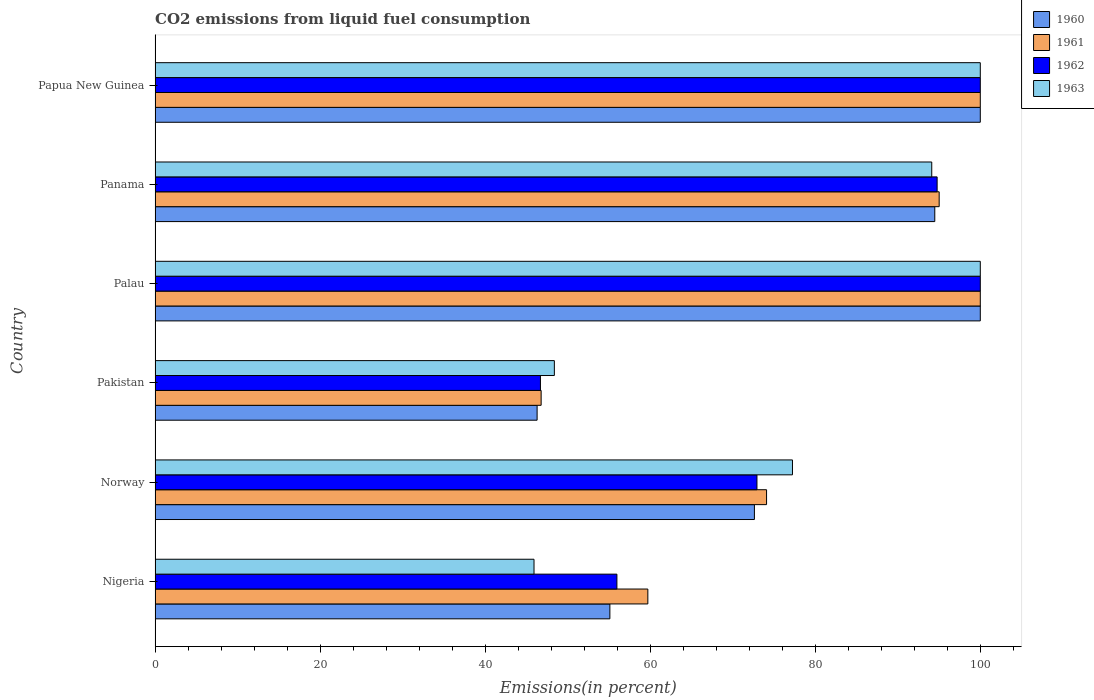How many groups of bars are there?
Give a very brief answer. 6. Are the number of bars on each tick of the Y-axis equal?
Provide a short and direct response. Yes. How many bars are there on the 5th tick from the top?
Offer a very short reply. 4. What is the label of the 3rd group of bars from the top?
Keep it short and to the point. Palau. In how many cases, is the number of bars for a given country not equal to the number of legend labels?
Offer a terse response. 0. Across all countries, what is the minimum total CO2 emitted in 1960?
Offer a very short reply. 46.3. In which country was the total CO2 emitted in 1960 maximum?
Your response must be concise. Palau. What is the total total CO2 emitted in 1962 in the graph?
Your answer should be compact. 470.37. What is the difference between the total CO2 emitted in 1961 in Norway and that in Pakistan?
Your answer should be very brief. 27.32. What is the difference between the total CO2 emitted in 1963 in Nigeria and the total CO2 emitted in 1960 in Palau?
Your response must be concise. -54.08. What is the average total CO2 emitted in 1960 per country?
Offer a very short reply. 78.09. What is the difference between the total CO2 emitted in 1960 and total CO2 emitted in 1961 in Norway?
Offer a very short reply. -1.47. In how many countries, is the total CO2 emitted in 1961 greater than 80 %?
Provide a short and direct response. 3. What is the ratio of the total CO2 emitted in 1961 in Norway to that in Pakistan?
Offer a terse response. 1.58. Is the difference between the total CO2 emitted in 1960 in Nigeria and Panama greater than the difference between the total CO2 emitted in 1961 in Nigeria and Panama?
Make the answer very short. No. What is the difference between the highest and the lowest total CO2 emitted in 1961?
Ensure brevity in your answer.  53.21. In how many countries, is the total CO2 emitted in 1960 greater than the average total CO2 emitted in 1960 taken over all countries?
Give a very brief answer. 3. Is the sum of the total CO2 emitted in 1961 in Nigeria and Papua New Guinea greater than the maximum total CO2 emitted in 1962 across all countries?
Keep it short and to the point. Yes. Is it the case that in every country, the sum of the total CO2 emitted in 1962 and total CO2 emitted in 1963 is greater than the sum of total CO2 emitted in 1961 and total CO2 emitted in 1960?
Offer a very short reply. No. What does the 3rd bar from the bottom in Panama represents?
Provide a succinct answer. 1962. How many bars are there?
Offer a very short reply. 24. Are all the bars in the graph horizontal?
Provide a succinct answer. Yes. What is the difference between two consecutive major ticks on the X-axis?
Your answer should be very brief. 20. Does the graph contain grids?
Make the answer very short. No. How many legend labels are there?
Ensure brevity in your answer.  4. How are the legend labels stacked?
Your response must be concise. Vertical. What is the title of the graph?
Offer a very short reply. CO2 emissions from liquid fuel consumption. Does "1969" appear as one of the legend labels in the graph?
Provide a short and direct response. No. What is the label or title of the X-axis?
Give a very brief answer. Emissions(in percent). What is the label or title of the Y-axis?
Offer a terse response. Country. What is the Emissions(in percent) of 1960 in Nigeria?
Give a very brief answer. 55.11. What is the Emissions(in percent) of 1961 in Nigeria?
Offer a terse response. 59.71. What is the Emissions(in percent) of 1962 in Nigeria?
Keep it short and to the point. 55.96. What is the Emissions(in percent) in 1963 in Nigeria?
Your answer should be compact. 45.92. What is the Emissions(in percent) in 1960 in Norway?
Offer a very short reply. 72.63. What is the Emissions(in percent) in 1961 in Norway?
Keep it short and to the point. 74.1. What is the Emissions(in percent) in 1962 in Norway?
Your answer should be very brief. 72.94. What is the Emissions(in percent) in 1963 in Norway?
Provide a succinct answer. 77.24. What is the Emissions(in percent) of 1960 in Pakistan?
Ensure brevity in your answer.  46.3. What is the Emissions(in percent) of 1961 in Pakistan?
Provide a succinct answer. 46.79. What is the Emissions(in percent) of 1962 in Pakistan?
Give a very brief answer. 46.7. What is the Emissions(in percent) of 1963 in Pakistan?
Your answer should be compact. 48.39. What is the Emissions(in percent) of 1961 in Palau?
Your response must be concise. 100. What is the Emissions(in percent) of 1962 in Palau?
Make the answer very short. 100. What is the Emissions(in percent) of 1963 in Palau?
Your answer should be very brief. 100. What is the Emissions(in percent) of 1960 in Panama?
Your answer should be very brief. 94.49. What is the Emissions(in percent) of 1961 in Panama?
Your answer should be very brief. 95.02. What is the Emissions(in percent) in 1962 in Panama?
Your answer should be very brief. 94.77. What is the Emissions(in percent) in 1963 in Panama?
Give a very brief answer. 94.12. What is the Emissions(in percent) in 1962 in Papua New Guinea?
Offer a terse response. 100. What is the Emissions(in percent) of 1963 in Papua New Guinea?
Your answer should be compact. 100. Across all countries, what is the maximum Emissions(in percent) of 1960?
Offer a terse response. 100. Across all countries, what is the maximum Emissions(in percent) in 1962?
Offer a terse response. 100. Across all countries, what is the maximum Emissions(in percent) in 1963?
Your answer should be very brief. 100. Across all countries, what is the minimum Emissions(in percent) of 1960?
Provide a succinct answer. 46.3. Across all countries, what is the minimum Emissions(in percent) of 1961?
Give a very brief answer. 46.79. Across all countries, what is the minimum Emissions(in percent) of 1962?
Offer a very short reply. 46.7. Across all countries, what is the minimum Emissions(in percent) in 1963?
Give a very brief answer. 45.92. What is the total Emissions(in percent) in 1960 in the graph?
Offer a very short reply. 468.52. What is the total Emissions(in percent) of 1961 in the graph?
Offer a terse response. 475.62. What is the total Emissions(in percent) in 1962 in the graph?
Provide a short and direct response. 470.37. What is the total Emissions(in percent) of 1963 in the graph?
Provide a succinct answer. 465.66. What is the difference between the Emissions(in percent) in 1960 in Nigeria and that in Norway?
Keep it short and to the point. -17.52. What is the difference between the Emissions(in percent) of 1961 in Nigeria and that in Norway?
Offer a very short reply. -14.39. What is the difference between the Emissions(in percent) in 1962 in Nigeria and that in Norway?
Keep it short and to the point. -16.97. What is the difference between the Emissions(in percent) in 1963 in Nigeria and that in Norway?
Provide a succinct answer. -31.32. What is the difference between the Emissions(in percent) in 1960 in Nigeria and that in Pakistan?
Offer a terse response. 8.82. What is the difference between the Emissions(in percent) in 1961 in Nigeria and that in Pakistan?
Your answer should be compact. 12.93. What is the difference between the Emissions(in percent) of 1962 in Nigeria and that in Pakistan?
Offer a very short reply. 9.27. What is the difference between the Emissions(in percent) in 1963 in Nigeria and that in Pakistan?
Your answer should be very brief. -2.46. What is the difference between the Emissions(in percent) in 1960 in Nigeria and that in Palau?
Your response must be concise. -44.89. What is the difference between the Emissions(in percent) in 1961 in Nigeria and that in Palau?
Provide a succinct answer. -40.29. What is the difference between the Emissions(in percent) in 1962 in Nigeria and that in Palau?
Provide a short and direct response. -44.04. What is the difference between the Emissions(in percent) of 1963 in Nigeria and that in Palau?
Keep it short and to the point. -54.08. What is the difference between the Emissions(in percent) in 1960 in Nigeria and that in Panama?
Offer a very short reply. -39.37. What is the difference between the Emissions(in percent) of 1961 in Nigeria and that in Panama?
Offer a very short reply. -35.3. What is the difference between the Emissions(in percent) of 1962 in Nigeria and that in Panama?
Your response must be concise. -38.8. What is the difference between the Emissions(in percent) of 1963 in Nigeria and that in Panama?
Keep it short and to the point. -48.2. What is the difference between the Emissions(in percent) in 1960 in Nigeria and that in Papua New Guinea?
Ensure brevity in your answer.  -44.89. What is the difference between the Emissions(in percent) in 1961 in Nigeria and that in Papua New Guinea?
Your answer should be very brief. -40.29. What is the difference between the Emissions(in percent) in 1962 in Nigeria and that in Papua New Guinea?
Your answer should be very brief. -44.04. What is the difference between the Emissions(in percent) in 1963 in Nigeria and that in Papua New Guinea?
Offer a terse response. -54.08. What is the difference between the Emissions(in percent) in 1960 in Norway and that in Pakistan?
Your response must be concise. 26.33. What is the difference between the Emissions(in percent) in 1961 in Norway and that in Pakistan?
Give a very brief answer. 27.32. What is the difference between the Emissions(in percent) of 1962 in Norway and that in Pakistan?
Your response must be concise. 26.24. What is the difference between the Emissions(in percent) of 1963 in Norway and that in Pakistan?
Make the answer very short. 28.85. What is the difference between the Emissions(in percent) of 1960 in Norway and that in Palau?
Make the answer very short. -27.37. What is the difference between the Emissions(in percent) in 1961 in Norway and that in Palau?
Ensure brevity in your answer.  -25.9. What is the difference between the Emissions(in percent) of 1962 in Norway and that in Palau?
Keep it short and to the point. -27.06. What is the difference between the Emissions(in percent) in 1963 in Norway and that in Palau?
Offer a very short reply. -22.76. What is the difference between the Emissions(in percent) in 1960 in Norway and that in Panama?
Your answer should be very brief. -21.86. What is the difference between the Emissions(in percent) in 1961 in Norway and that in Panama?
Give a very brief answer. -20.92. What is the difference between the Emissions(in percent) in 1962 in Norway and that in Panama?
Provide a succinct answer. -21.83. What is the difference between the Emissions(in percent) of 1963 in Norway and that in Panama?
Offer a terse response. -16.88. What is the difference between the Emissions(in percent) of 1960 in Norway and that in Papua New Guinea?
Your response must be concise. -27.37. What is the difference between the Emissions(in percent) in 1961 in Norway and that in Papua New Guinea?
Provide a short and direct response. -25.9. What is the difference between the Emissions(in percent) in 1962 in Norway and that in Papua New Guinea?
Ensure brevity in your answer.  -27.06. What is the difference between the Emissions(in percent) in 1963 in Norway and that in Papua New Guinea?
Give a very brief answer. -22.76. What is the difference between the Emissions(in percent) in 1960 in Pakistan and that in Palau?
Make the answer very short. -53.7. What is the difference between the Emissions(in percent) of 1961 in Pakistan and that in Palau?
Ensure brevity in your answer.  -53.21. What is the difference between the Emissions(in percent) of 1962 in Pakistan and that in Palau?
Offer a terse response. -53.3. What is the difference between the Emissions(in percent) of 1963 in Pakistan and that in Palau?
Offer a very short reply. -51.61. What is the difference between the Emissions(in percent) of 1960 in Pakistan and that in Panama?
Your answer should be compact. -48.19. What is the difference between the Emissions(in percent) in 1961 in Pakistan and that in Panama?
Your response must be concise. -48.23. What is the difference between the Emissions(in percent) in 1962 in Pakistan and that in Panama?
Offer a terse response. -48.07. What is the difference between the Emissions(in percent) in 1963 in Pakistan and that in Panama?
Offer a terse response. -45.73. What is the difference between the Emissions(in percent) in 1960 in Pakistan and that in Papua New Guinea?
Make the answer very short. -53.7. What is the difference between the Emissions(in percent) of 1961 in Pakistan and that in Papua New Guinea?
Offer a terse response. -53.21. What is the difference between the Emissions(in percent) of 1962 in Pakistan and that in Papua New Guinea?
Provide a succinct answer. -53.3. What is the difference between the Emissions(in percent) of 1963 in Pakistan and that in Papua New Guinea?
Your answer should be compact. -51.61. What is the difference between the Emissions(in percent) of 1960 in Palau and that in Panama?
Your response must be concise. 5.51. What is the difference between the Emissions(in percent) in 1961 in Palau and that in Panama?
Provide a short and direct response. 4.98. What is the difference between the Emissions(in percent) of 1962 in Palau and that in Panama?
Your answer should be compact. 5.23. What is the difference between the Emissions(in percent) in 1963 in Palau and that in Panama?
Give a very brief answer. 5.88. What is the difference between the Emissions(in percent) in 1960 in Palau and that in Papua New Guinea?
Offer a very short reply. 0. What is the difference between the Emissions(in percent) of 1961 in Palau and that in Papua New Guinea?
Offer a terse response. 0. What is the difference between the Emissions(in percent) of 1962 in Palau and that in Papua New Guinea?
Offer a terse response. 0. What is the difference between the Emissions(in percent) of 1960 in Panama and that in Papua New Guinea?
Keep it short and to the point. -5.51. What is the difference between the Emissions(in percent) in 1961 in Panama and that in Papua New Guinea?
Your response must be concise. -4.98. What is the difference between the Emissions(in percent) of 1962 in Panama and that in Papua New Guinea?
Offer a very short reply. -5.23. What is the difference between the Emissions(in percent) in 1963 in Panama and that in Papua New Guinea?
Your response must be concise. -5.88. What is the difference between the Emissions(in percent) in 1960 in Nigeria and the Emissions(in percent) in 1961 in Norway?
Your answer should be very brief. -18.99. What is the difference between the Emissions(in percent) in 1960 in Nigeria and the Emissions(in percent) in 1962 in Norway?
Your answer should be very brief. -17.82. What is the difference between the Emissions(in percent) in 1960 in Nigeria and the Emissions(in percent) in 1963 in Norway?
Your response must be concise. -22.13. What is the difference between the Emissions(in percent) of 1961 in Nigeria and the Emissions(in percent) of 1962 in Norway?
Give a very brief answer. -13.22. What is the difference between the Emissions(in percent) of 1961 in Nigeria and the Emissions(in percent) of 1963 in Norway?
Your answer should be compact. -17.52. What is the difference between the Emissions(in percent) in 1962 in Nigeria and the Emissions(in percent) in 1963 in Norway?
Give a very brief answer. -21.27. What is the difference between the Emissions(in percent) in 1960 in Nigeria and the Emissions(in percent) in 1961 in Pakistan?
Your answer should be compact. 8.33. What is the difference between the Emissions(in percent) in 1960 in Nigeria and the Emissions(in percent) in 1962 in Pakistan?
Make the answer very short. 8.41. What is the difference between the Emissions(in percent) in 1960 in Nigeria and the Emissions(in percent) in 1963 in Pakistan?
Provide a short and direct response. 6.73. What is the difference between the Emissions(in percent) of 1961 in Nigeria and the Emissions(in percent) of 1962 in Pakistan?
Provide a succinct answer. 13.02. What is the difference between the Emissions(in percent) in 1961 in Nigeria and the Emissions(in percent) in 1963 in Pakistan?
Keep it short and to the point. 11.33. What is the difference between the Emissions(in percent) in 1962 in Nigeria and the Emissions(in percent) in 1963 in Pakistan?
Your answer should be very brief. 7.58. What is the difference between the Emissions(in percent) of 1960 in Nigeria and the Emissions(in percent) of 1961 in Palau?
Provide a short and direct response. -44.89. What is the difference between the Emissions(in percent) in 1960 in Nigeria and the Emissions(in percent) in 1962 in Palau?
Make the answer very short. -44.89. What is the difference between the Emissions(in percent) in 1960 in Nigeria and the Emissions(in percent) in 1963 in Palau?
Ensure brevity in your answer.  -44.89. What is the difference between the Emissions(in percent) in 1961 in Nigeria and the Emissions(in percent) in 1962 in Palau?
Your answer should be very brief. -40.29. What is the difference between the Emissions(in percent) of 1961 in Nigeria and the Emissions(in percent) of 1963 in Palau?
Your answer should be compact. -40.29. What is the difference between the Emissions(in percent) of 1962 in Nigeria and the Emissions(in percent) of 1963 in Palau?
Make the answer very short. -44.04. What is the difference between the Emissions(in percent) of 1960 in Nigeria and the Emissions(in percent) of 1961 in Panama?
Ensure brevity in your answer.  -39.9. What is the difference between the Emissions(in percent) in 1960 in Nigeria and the Emissions(in percent) in 1962 in Panama?
Your response must be concise. -39.66. What is the difference between the Emissions(in percent) in 1960 in Nigeria and the Emissions(in percent) in 1963 in Panama?
Provide a short and direct response. -39. What is the difference between the Emissions(in percent) of 1961 in Nigeria and the Emissions(in percent) of 1962 in Panama?
Keep it short and to the point. -35.05. What is the difference between the Emissions(in percent) in 1961 in Nigeria and the Emissions(in percent) in 1963 in Panama?
Offer a very short reply. -34.4. What is the difference between the Emissions(in percent) in 1962 in Nigeria and the Emissions(in percent) in 1963 in Panama?
Offer a very short reply. -38.15. What is the difference between the Emissions(in percent) of 1960 in Nigeria and the Emissions(in percent) of 1961 in Papua New Guinea?
Your response must be concise. -44.89. What is the difference between the Emissions(in percent) in 1960 in Nigeria and the Emissions(in percent) in 1962 in Papua New Guinea?
Provide a short and direct response. -44.89. What is the difference between the Emissions(in percent) in 1960 in Nigeria and the Emissions(in percent) in 1963 in Papua New Guinea?
Offer a very short reply. -44.89. What is the difference between the Emissions(in percent) in 1961 in Nigeria and the Emissions(in percent) in 1962 in Papua New Guinea?
Offer a terse response. -40.29. What is the difference between the Emissions(in percent) of 1961 in Nigeria and the Emissions(in percent) of 1963 in Papua New Guinea?
Give a very brief answer. -40.29. What is the difference between the Emissions(in percent) in 1962 in Nigeria and the Emissions(in percent) in 1963 in Papua New Guinea?
Ensure brevity in your answer.  -44.04. What is the difference between the Emissions(in percent) in 1960 in Norway and the Emissions(in percent) in 1961 in Pakistan?
Offer a terse response. 25.84. What is the difference between the Emissions(in percent) of 1960 in Norway and the Emissions(in percent) of 1962 in Pakistan?
Keep it short and to the point. 25.93. What is the difference between the Emissions(in percent) of 1960 in Norway and the Emissions(in percent) of 1963 in Pakistan?
Your answer should be compact. 24.24. What is the difference between the Emissions(in percent) in 1961 in Norway and the Emissions(in percent) in 1962 in Pakistan?
Your answer should be very brief. 27.4. What is the difference between the Emissions(in percent) in 1961 in Norway and the Emissions(in percent) in 1963 in Pakistan?
Offer a terse response. 25.71. What is the difference between the Emissions(in percent) in 1962 in Norway and the Emissions(in percent) in 1963 in Pakistan?
Make the answer very short. 24.55. What is the difference between the Emissions(in percent) of 1960 in Norway and the Emissions(in percent) of 1961 in Palau?
Make the answer very short. -27.37. What is the difference between the Emissions(in percent) of 1960 in Norway and the Emissions(in percent) of 1962 in Palau?
Keep it short and to the point. -27.37. What is the difference between the Emissions(in percent) of 1960 in Norway and the Emissions(in percent) of 1963 in Palau?
Your answer should be compact. -27.37. What is the difference between the Emissions(in percent) in 1961 in Norway and the Emissions(in percent) in 1962 in Palau?
Your answer should be very brief. -25.9. What is the difference between the Emissions(in percent) in 1961 in Norway and the Emissions(in percent) in 1963 in Palau?
Your answer should be very brief. -25.9. What is the difference between the Emissions(in percent) in 1962 in Norway and the Emissions(in percent) in 1963 in Palau?
Offer a very short reply. -27.06. What is the difference between the Emissions(in percent) of 1960 in Norway and the Emissions(in percent) of 1961 in Panama?
Make the answer very short. -22.39. What is the difference between the Emissions(in percent) of 1960 in Norway and the Emissions(in percent) of 1962 in Panama?
Your response must be concise. -22.14. What is the difference between the Emissions(in percent) in 1960 in Norway and the Emissions(in percent) in 1963 in Panama?
Provide a succinct answer. -21.49. What is the difference between the Emissions(in percent) in 1961 in Norway and the Emissions(in percent) in 1962 in Panama?
Make the answer very short. -20.67. What is the difference between the Emissions(in percent) in 1961 in Norway and the Emissions(in percent) in 1963 in Panama?
Your answer should be compact. -20.02. What is the difference between the Emissions(in percent) in 1962 in Norway and the Emissions(in percent) in 1963 in Panama?
Offer a very short reply. -21.18. What is the difference between the Emissions(in percent) in 1960 in Norway and the Emissions(in percent) in 1961 in Papua New Guinea?
Give a very brief answer. -27.37. What is the difference between the Emissions(in percent) in 1960 in Norway and the Emissions(in percent) in 1962 in Papua New Guinea?
Offer a terse response. -27.37. What is the difference between the Emissions(in percent) of 1960 in Norway and the Emissions(in percent) of 1963 in Papua New Guinea?
Provide a succinct answer. -27.37. What is the difference between the Emissions(in percent) of 1961 in Norway and the Emissions(in percent) of 1962 in Papua New Guinea?
Make the answer very short. -25.9. What is the difference between the Emissions(in percent) in 1961 in Norway and the Emissions(in percent) in 1963 in Papua New Guinea?
Make the answer very short. -25.9. What is the difference between the Emissions(in percent) of 1962 in Norway and the Emissions(in percent) of 1963 in Papua New Guinea?
Offer a terse response. -27.06. What is the difference between the Emissions(in percent) in 1960 in Pakistan and the Emissions(in percent) in 1961 in Palau?
Your answer should be very brief. -53.7. What is the difference between the Emissions(in percent) of 1960 in Pakistan and the Emissions(in percent) of 1962 in Palau?
Your answer should be compact. -53.7. What is the difference between the Emissions(in percent) of 1960 in Pakistan and the Emissions(in percent) of 1963 in Palau?
Make the answer very short. -53.7. What is the difference between the Emissions(in percent) in 1961 in Pakistan and the Emissions(in percent) in 1962 in Palau?
Offer a terse response. -53.21. What is the difference between the Emissions(in percent) in 1961 in Pakistan and the Emissions(in percent) in 1963 in Palau?
Ensure brevity in your answer.  -53.21. What is the difference between the Emissions(in percent) of 1962 in Pakistan and the Emissions(in percent) of 1963 in Palau?
Provide a succinct answer. -53.3. What is the difference between the Emissions(in percent) of 1960 in Pakistan and the Emissions(in percent) of 1961 in Panama?
Provide a short and direct response. -48.72. What is the difference between the Emissions(in percent) in 1960 in Pakistan and the Emissions(in percent) in 1962 in Panama?
Your response must be concise. -48.47. What is the difference between the Emissions(in percent) in 1960 in Pakistan and the Emissions(in percent) in 1963 in Panama?
Provide a succinct answer. -47.82. What is the difference between the Emissions(in percent) of 1961 in Pakistan and the Emissions(in percent) of 1962 in Panama?
Your answer should be very brief. -47.98. What is the difference between the Emissions(in percent) of 1961 in Pakistan and the Emissions(in percent) of 1963 in Panama?
Your response must be concise. -47.33. What is the difference between the Emissions(in percent) in 1962 in Pakistan and the Emissions(in percent) in 1963 in Panama?
Offer a very short reply. -47.42. What is the difference between the Emissions(in percent) of 1960 in Pakistan and the Emissions(in percent) of 1961 in Papua New Guinea?
Ensure brevity in your answer.  -53.7. What is the difference between the Emissions(in percent) of 1960 in Pakistan and the Emissions(in percent) of 1962 in Papua New Guinea?
Offer a very short reply. -53.7. What is the difference between the Emissions(in percent) in 1960 in Pakistan and the Emissions(in percent) in 1963 in Papua New Guinea?
Provide a short and direct response. -53.7. What is the difference between the Emissions(in percent) of 1961 in Pakistan and the Emissions(in percent) of 1962 in Papua New Guinea?
Your answer should be very brief. -53.21. What is the difference between the Emissions(in percent) of 1961 in Pakistan and the Emissions(in percent) of 1963 in Papua New Guinea?
Your answer should be very brief. -53.21. What is the difference between the Emissions(in percent) in 1962 in Pakistan and the Emissions(in percent) in 1963 in Papua New Guinea?
Provide a succinct answer. -53.3. What is the difference between the Emissions(in percent) of 1960 in Palau and the Emissions(in percent) of 1961 in Panama?
Your response must be concise. 4.98. What is the difference between the Emissions(in percent) in 1960 in Palau and the Emissions(in percent) in 1962 in Panama?
Your answer should be compact. 5.23. What is the difference between the Emissions(in percent) of 1960 in Palau and the Emissions(in percent) of 1963 in Panama?
Ensure brevity in your answer.  5.88. What is the difference between the Emissions(in percent) in 1961 in Palau and the Emissions(in percent) in 1962 in Panama?
Offer a very short reply. 5.23. What is the difference between the Emissions(in percent) of 1961 in Palau and the Emissions(in percent) of 1963 in Panama?
Keep it short and to the point. 5.88. What is the difference between the Emissions(in percent) in 1962 in Palau and the Emissions(in percent) in 1963 in Panama?
Ensure brevity in your answer.  5.88. What is the difference between the Emissions(in percent) in 1960 in Palau and the Emissions(in percent) in 1962 in Papua New Guinea?
Make the answer very short. 0. What is the difference between the Emissions(in percent) in 1960 in Palau and the Emissions(in percent) in 1963 in Papua New Guinea?
Keep it short and to the point. 0. What is the difference between the Emissions(in percent) in 1961 in Palau and the Emissions(in percent) in 1962 in Papua New Guinea?
Make the answer very short. 0. What is the difference between the Emissions(in percent) of 1961 in Palau and the Emissions(in percent) of 1963 in Papua New Guinea?
Your answer should be compact. 0. What is the difference between the Emissions(in percent) of 1960 in Panama and the Emissions(in percent) of 1961 in Papua New Guinea?
Keep it short and to the point. -5.51. What is the difference between the Emissions(in percent) in 1960 in Panama and the Emissions(in percent) in 1962 in Papua New Guinea?
Your answer should be compact. -5.51. What is the difference between the Emissions(in percent) of 1960 in Panama and the Emissions(in percent) of 1963 in Papua New Guinea?
Provide a short and direct response. -5.51. What is the difference between the Emissions(in percent) of 1961 in Panama and the Emissions(in percent) of 1962 in Papua New Guinea?
Ensure brevity in your answer.  -4.98. What is the difference between the Emissions(in percent) of 1961 in Panama and the Emissions(in percent) of 1963 in Papua New Guinea?
Your answer should be very brief. -4.98. What is the difference between the Emissions(in percent) of 1962 in Panama and the Emissions(in percent) of 1963 in Papua New Guinea?
Your response must be concise. -5.23. What is the average Emissions(in percent) of 1960 per country?
Give a very brief answer. 78.09. What is the average Emissions(in percent) of 1961 per country?
Keep it short and to the point. 79.27. What is the average Emissions(in percent) of 1962 per country?
Offer a very short reply. 78.39. What is the average Emissions(in percent) in 1963 per country?
Offer a terse response. 77.61. What is the difference between the Emissions(in percent) of 1960 and Emissions(in percent) of 1961 in Nigeria?
Ensure brevity in your answer.  -4.6. What is the difference between the Emissions(in percent) in 1960 and Emissions(in percent) in 1962 in Nigeria?
Provide a succinct answer. -0.85. What is the difference between the Emissions(in percent) of 1960 and Emissions(in percent) of 1963 in Nigeria?
Make the answer very short. 9.19. What is the difference between the Emissions(in percent) in 1961 and Emissions(in percent) in 1962 in Nigeria?
Your answer should be compact. 3.75. What is the difference between the Emissions(in percent) in 1961 and Emissions(in percent) in 1963 in Nigeria?
Offer a terse response. 13.79. What is the difference between the Emissions(in percent) of 1962 and Emissions(in percent) of 1963 in Nigeria?
Your answer should be compact. 10.04. What is the difference between the Emissions(in percent) in 1960 and Emissions(in percent) in 1961 in Norway?
Your response must be concise. -1.47. What is the difference between the Emissions(in percent) of 1960 and Emissions(in percent) of 1962 in Norway?
Your answer should be very brief. -0.31. What is the difference between the Emissions(in percent) in 1960 and Emissions(in percent) in 1963 in Norway?
Provide a short and direct response. -4.61. What is the difference between the Emissions(in percent) in 1961 and Emissions(in percent) in 1962 in Norway?
Give a very brief answer. 1.16. What is the difference between the Emissions(in percent) in 1961 and Emissions(in percent) in 1963 in Norway?
Ensure brevity in your answer.  -3.14. What is the difference between the Emissions(in percent) of 1962 and Emissions(in percent) of 1963 in Norway?
Your answer should be very brief. -4.3. What is the difference between the Emissions(in percent) in 1960 and Emissions(in percent) in 1961 in Pakistan?
Offer a terse response. -0.49. What is the difference between the Emissions(in percent) of 1960 and Emissions(in percent) of 1962 in Pakistan?
Keep it short and to the point. -0.4. What is the difference between the Emissions(in percent) of 1960 and Emissions(in percent) of 1963 in Pakistan?
Your answer should be very brief. -2.09. What is the difference between the Emissions(in percent) of 1961 and Emissions(in percent) of 1962 in Pakistan?
Give a very brief answer. 0.09. What is the difference between the Emissions(in percent) in 1961 and Emissions(in percent) in 1963 in Pakistan?
Offer a terse response. -1.6. What is the difference between the Emissions(in percent) of 1962 and Emissions(in percent) of 1963 in Pakistan?
Offer a very short reply. -1.69. What is the difference between the Emissions(in percent) in 1960 and Emissions(in percent) in 1963 in Palau?
Ensure brevity in your answer.  0. What is the difference between the Emissions(in percent) in 1961 and Emissions(in percent) in 1963 in Palau?
Your response must be concise. 0. What is the difference between the Emissions(in percent) of 1962 and Emissions(in percent) of 1963 in Palau?
Your answer should be very brief. 0. What is the difference between the Emissions(in percent) in 1960 and Emissions(in percent) in 1961 in Panama?
Provide a short and direct response. -0.53. What is the difference between the Emissions(in percent) in 1960 and Emissions(in percent) in 1962 in Panama?
Your answer should be compact. -0.28. What is the difference between the Emissions(in percent) of 1960 and Emissions(in percent) of 1963 in Panama?
Ensure brevity in your answer.  0.37. What is the difference between the Emissions(in percent) in 1961 and Emissions(in percent) in 1962 in Panama?
Give a very brief answer. 0.25. What is the difference between the Emissions(in percent) of 1961 and Emissions(in percent) of 1963 in Panama?
Provide a succinct answer. 0.9. What is the difference between the Emissions(in percent) in 1962 and Emissions(in percent) in 1963 in Panama?
Your response must be concise. 0.65. What is the difference between the Emissions(in percent) of 1960 and Emissions(in percent) of 1961 in Papua New Guinea?
Make the answer very short. 0. What is the difference between the Emissions(in percent) in 1960 and Emissions(in percent) in 1963 in Papua New Guinea?
Your answer should be compact. 0. What is the difference between the Emissions(in percent) of 1961 and Emissions(in percent) of 1962 in Papua New Guinea?
Make the answer very short. 0. What is the difference between the Emissions(in percent) of 1962 and Emissions(in percent) of 1963 in Papua New Guinea?
Provide a short and direct response. 0. What is the ratio of the Emissions(in percent) of 1960 in Nigeria to that in Norway?
Your answer should be very brief. 0.76. What is the ratio of the Emissions(in percent) in 1961 in Nigeria to that in Norway?
Provide a succinct answer. 0.81. What is the ratio of the Emissions(in percent) in 1962 in Nigeria to that in Norway?
Give a very brief answer. 0.77. What is the ratio of the Emissions(in percent) of 1963 in Nigeria to that in Norway?
Make the answer very short. 0.59. What is the ratio of the Emissions(in percent) in 1960 in Nigeria to that in Pakistan?
Provide a succinct answer. 1.19. What is the ratio of the Emissions(in percent) of 1961 in Nigeria to that in Pakistan?
Provide a succinct answer. 1.28. What is the ratio of the Emissions(in percent) of 1962 in Nigeria to that in Pakistan?
Your answer should be compact. 1.2. What is the ratio of the Emissions(in percent) in 1963 in Nigeria to that in Pakistan?
Make the answer very short. 0.95. What is the ratio of the Emissions(in percent) in 1960 in Nigeria to that in Palau?
Keep it short and to the point. 0.55. What is the ratio of the Emissions(in percent) in 1961 in Nigeria to that in Palau?
Keep it short and to the point. 0.6. What is the ratio of the Emissions(in percent) in 1962 in Nigeria to that in Palau?
Offer a very short reply. 0.56. What is the ratio of the Emissions(in percent) of 1963 in Nigeria to that in Palau?
Your response must be concise. 0.46. What is the ratio of the Emissions(in percent) in 1960 in Nigeria to that in Panama?
Offer a very short reply. 0.58. What is the ratio of the Emissions(in percent) in 1961 in Nigeria to that in Panama?
Offer a terse response. 0.63. What is the ratio of the Emissions(in percent) in 1962 in Nigeria to that in Panama?
Give a very brief answer. 0.59. What is the ratio of the Emissions(in percent) in 1963 in Nigeria to that in Panama?
Keep it short and to the point. 0.49. What is the ratio of the Emissions(in percent) in 1960 in Nigeria to that in Papua New Guinea?
Provide a succinct answer. 0.55. What is the ratio of the Emissions(in percent) of 1961 in Nigeria to that in Papua New Guinea?
Provide a short and direct response. 0.6. What is the ratio of the Emissions(in percent) of 1962 in Nigeria to that in Papua New Guinea?
Your answer should be compact. 0.56. What is the ratio of the Emissions(in percent) of 1963 in Nigeria to that in Papua New Guinea?
Give a very brief answer. 0.46. What is the ratio of the Emissions(in percent) in 1960 in Norway to that in Pakistan?
Give a very brief answer. 1.57. What is the ratio of the Emissions(in percent) of 1961 in Norway to that in Pakistan?
Your answer should be very brief. 1.58. What is the ratio of the Emissions(in percent) in 1962 in Norway to that in Pakistan?
Give a very brief answer. 1.56. What is the ratio of the Emissions(in percent) in 1963 in Norway to that in Pakistan?
Provide a succinct answer. 1.6. What is the ratio of the Emissions(in percent) in 1960 in Norway to that in Palau?
Offer a very short reply. 0.73. What is the ratio of the Emissions(in percent) in 1961 in Norway to that in Palau?
Your answer should be compact. 0.74. What is the ratio of the Emissions(in percent) in 1962 in Norway to that in Palau?
Keep it short and to the point. 0.73. What is the ratio of the Emissions(in percent) of 1963 in Norway to that in Palau?
Provide a succinct answer. 0.77. What is the ratio of the Emissions(in percent) in 1960 in Norway to that in Panama?
Your answer should be compact. 0.77. What is the ratio of the Emissions(in percent) of 1961 in Norway to that in Panama?
Offer a very short reply. 0.78. What is the ratio of the Emissions(in percent) of 1962 in Norway to that in Panama?
Offer a terse response. 0.77. What is the ratio of the Emissions(in percent) of 1963 in Norway to that in Panama?
Keep it short and to the point. 0.82. What is the ratio of the Emissions(in percent) in 1960 in Norway to that in Papua New Guinea?
Keep it short and to the point. 0.73. What is the ratio of the Emissions(in percent) in 1961 in Norway to that in Papua New Guinea?
Provide a short and direct response. 0.74. What is the ratio of the Emissions(in percent) of 1962 in Norway to that in Papua New Guinea?
Offer a very short reply. 0.73. What is the ratio of the Emissions(in percent) in 1963 in Norway to that in Papua New Guinea?
Your answer should be very brief. 0.77. What is the ratio of the Emissions(in percent) of 1960 in Pakistan to that in Palau?
Provide a short and direct response. 0.46. What is the ratio of the Emissions(in percent) of 1961 in Pakistan to that in Palau?
Your answer should be compact. 0.47. What is the ratio of the Emissions(in percent) in 1962 in Pakistan to that in Palau?
Your answer should be very brief. 0.47. What is the ratio of the Emissions(in percent) of 1963 in Pakistan to that in Palau?
Offer a terse response. 0.48. What is the ratio of the Emissions(in percent) of 1960 in Pakistan to that in Panama?
Offer a very short reply. 0.49. What is the ratio of the Emissions(in percent) of 1961 in Pakistan to that in Panama?
Provide a succinct answer. 0.49. What is the ratio of the Emissions(in percent) in 1962 in Pakistan to that in Panama?
Keep it short and to the point. 0.49. What is the ratio of the Emissions(in percent) of 1963 in Pakistan to that in Panama?
Offer a very short reply. 0.51. What is the ratio of the Emissions(in percent) of 1960 in Pakistan to that in Papua New Guinea?
Your answer should be very brief. 0.46. What is the ratio of the Emissions(in percent) in 1961 in Pakistan to that in Papua New Guinea?
Offer a terse response. 0.47. What is the ratio of the Emissions(in percent) of 1962 in Pakistan to that in Papua New Guinea?
Your answer should be compact. 0.47. What is the ratio of the Emissions(in percent) in 1963 in Pakistan to that in Papua New Guinea?
Your answer should be compact. 0.48. What is the ratio of the Emissions(in percent) of 1960 in Palau to that in Panama?
Ensure brevity in your answer.  1.06. What is the ratio of the Emissions(in percent) of 1961 in Palau to that in Panama?
Your response must be concise. 1.05. What is the ratio of the Emissions(in percent) of 1962 in Palau to that in Panama?
Your answer should be compact. 1.06. What is the ratio of the Emissions(in percent) in 1963 in Palau to that in Panama?
Offer a terse response. 1.06. What is the ratio of the Emissions(in percent) of 1960 in Palau to that in Papua New Guinea?
Offer a terse response. 1. What is the ratio of the Emissions(in percent) in 1962 in Palau to that in Papua New Guinea?
Ensure brevity in your answer.  1. What is the ratio of the Emissions(in percent) in 1963 in Palau to that in Papua New Guinea?
Make the answer very short. 1. What is the ratio of the Emissions(in percent) of 1960 in Panama to that in Papua New Guinea?
Your answer should be compact. 0.94. What is the ratio of the Emissions(in percent) of 1961 in Panama to that in Papua New Guinea?
Your response must be concise. 0.95. What is the ratio of the Emissions(in percent) in 1962 in Panama to that in Papua New Guinea?
Make the answer very short. 0.95. What is the ratio of the Emissions(in percent) of 1963 in Panama to that in Papua New Guinea?
Your answer should be compact. 0.94. What is the difference between the highest and the second highest Emissions(in percent) in 1962?
Provide a succinct answer. 0. What is the difference between the highest and the second highest Emissions(in percent) of 1963?
Offer a terse response. 0. What is the difference between the highest and the lowest Emissions(in percent) in 1960?
Your answer should be very brief. 53.7. What is the difference between the highest and the lowest Emissions(in percent) in 1961?
Make the answer very short. 53.21. What is the difference between the highest and the lowest Emissions(in percent) of 1962?
Ensure brevity in your answer.  53.3. What is the difference between the highest and the lowest Emissions(in percent) in 1963?
Ensure brevity in your answer.  54.08. 